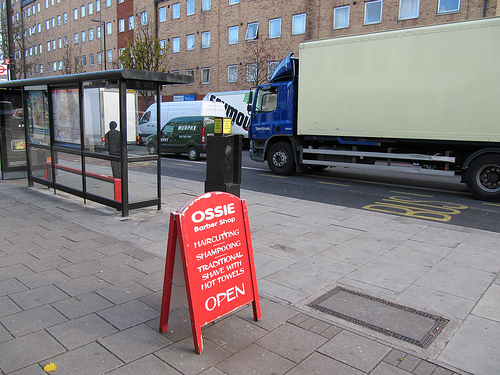<image>
Is there a truck behind the man? No. The truck is not behind the man. From this viewpoint, the truck appears to be positioned elsewhere in the scene. 